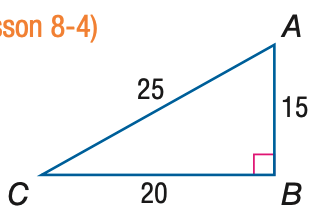Answer the mathemtical geometry problem and directly provide the correct option letter.
Question: Express the ratio of \cos C as a decimal to the nearest hundredth.
Choices: A: 0.60 B: 0.75 C: 0.80 D: 1.33 C 